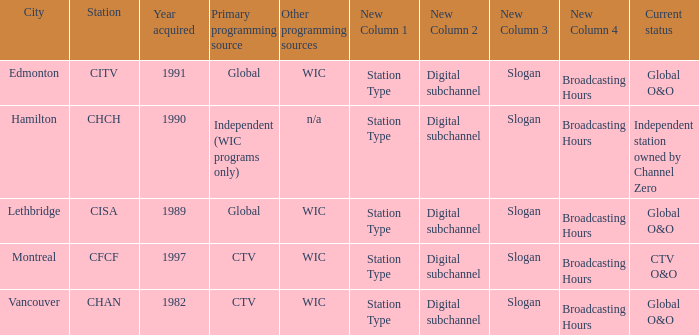How many channels were gained in 1997 1.0. 